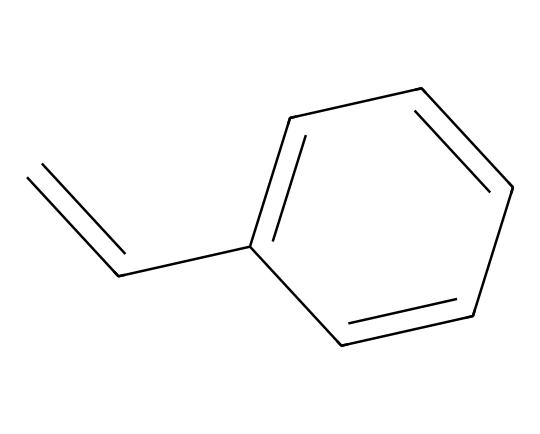What is the molecular formula of styrene? The molecular formula can be derived by counting the carbon and hydrogen atoms in the chemical structure. There are 8 carbon atoms (C) and 8 hydrogen atoms (H), leading to the molecular formula C8H8.
Answer: C8H8 How many double bonds are present in styrene? Upon examining the chemical structure, there is one double bond present between the carbon atoms at the beginning of the structure (C=C).
Answer: 1 What type of hybridization do the carbon atoms in the double bond have? The carbon atoms involved in the double bond are sp2 hybridized, as they each are bonded to one hydrogen atom, one carbon atom in the double bond, and one carbon atom in the aromatic ring, fulfilling the geometric requirements for sp2 hybridization.
Answer: sp2 What kind of functional group is indicated in styrene? The structure contains a phenyl group (a benzene ring) attached to an ethylene group, indicating that it is an alkene due to the presence of the double bond. The presence of the aromatic ring classifies it as both an aromatic compound and as a vinyl compound.
Answer: alkene What is the longest continuous carbon chain in styrene? Analyzing the structure, the longest continuous carbon chain includes the 2 carbon atoms from the ethenyl group and the 6 carbon atoms from the benzene ring, totaling 8 carbon atoms in a straight chain, which confirms the overall molecular connectivity.
Answer: 8 